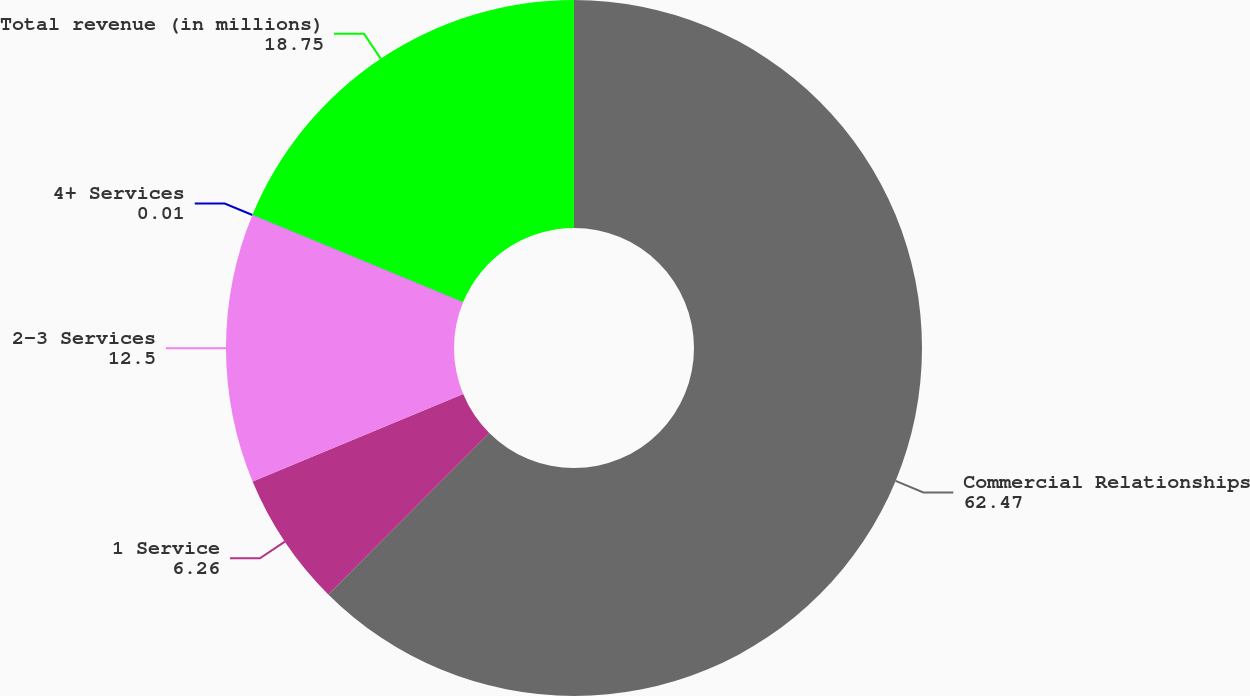Convert chart to OTSL. <chart><loc_0><loc_0><loc_500><loc_500><pie_chart><fcel>Commercial Relationships<fcel>1 Service<fcel>2-3 Services<fcel>4+ Services<fcel>Total revenue (in millions)<nl><fcel>62.47%<fcel>6.26%<fcel>12.5%<fcel>0.01%<fcel>18.75%<nl></chart> 